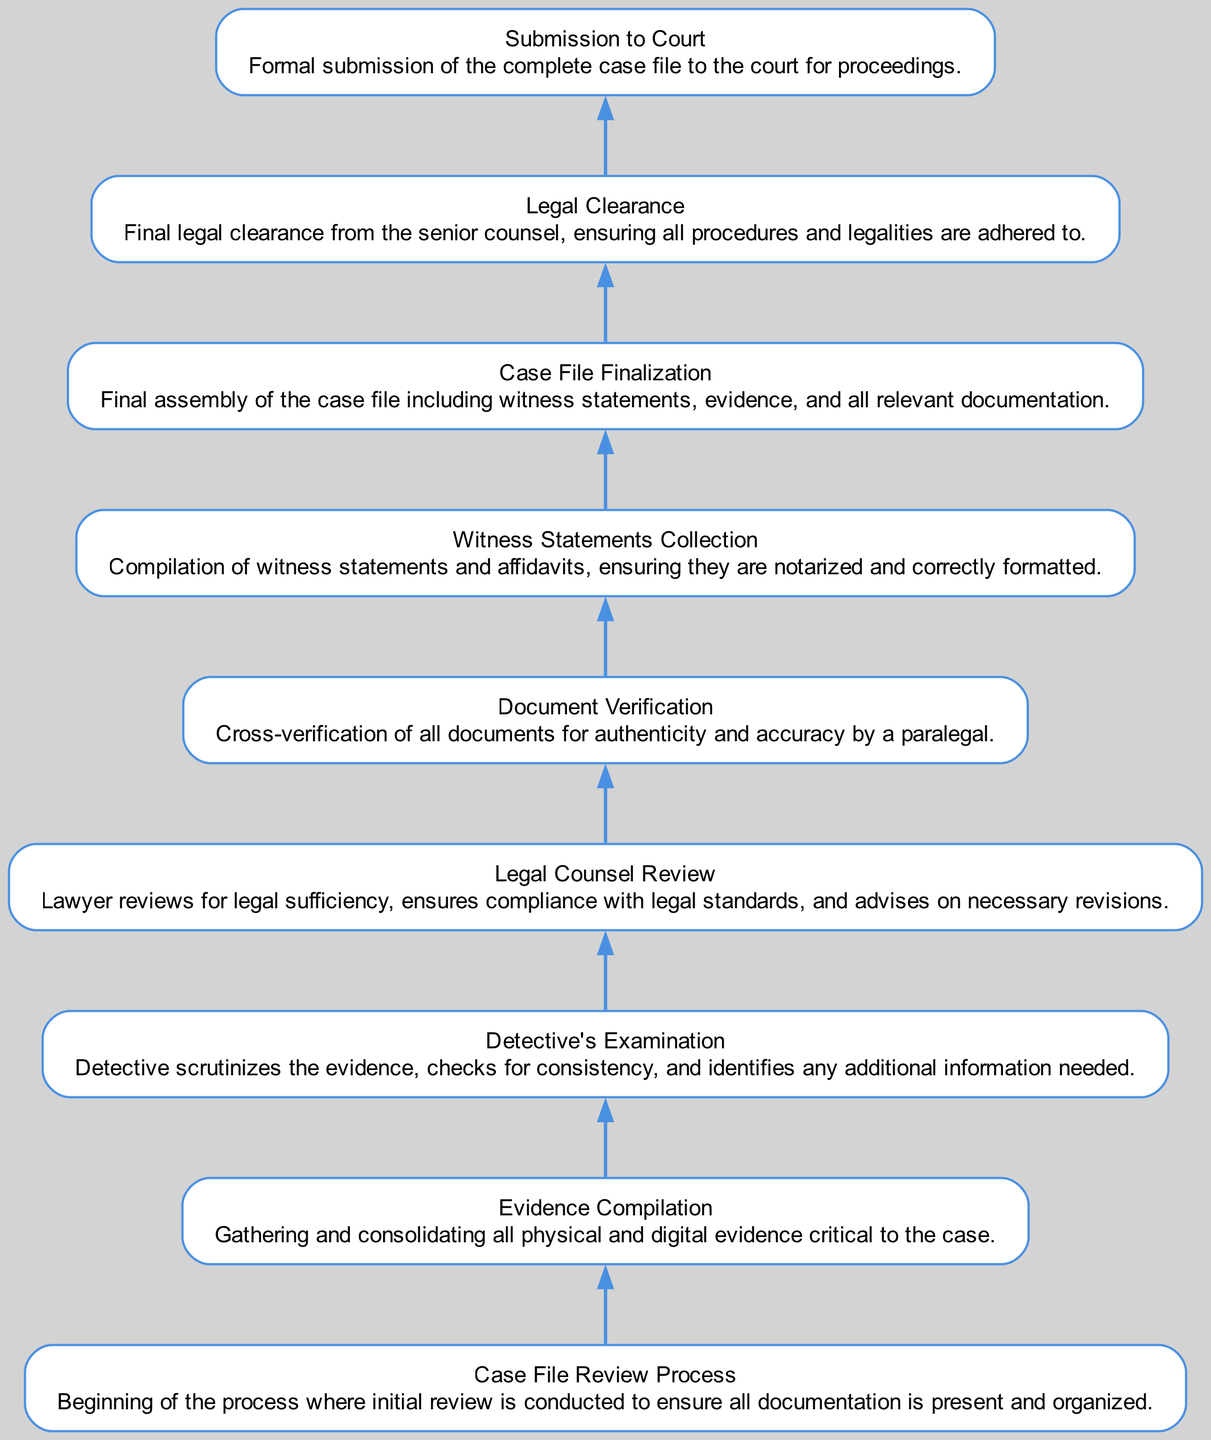What is the first step in the case file review process? The first step described in the diagram is "Case File Review Process," where the initial review is conducted to ensure all documentation is present and organized.
Answer: Case File Review Process How many total steps are there in the flowchart? By counting each distinct element in the diagram, there are nine steps listed in the case file review process.
Answer: Nine What is the function of "Document Verification" in the process? "Document Verification" involves the cross-verification of all documents for authenticity and accuracy by a paralegal, ensuring that all documentation is legally sound before submission.
Answer: Cross-verification Which step follows "Legal Counsel Review"? After "Legal Counsel Review," the next step in the process is "Document Verification." This transition indicates that after the legal review, verification of documents occurs.
Answer: Document Verification What happens immediately after "Case File Finalization"? Following "Case File Finalization," the next step is "Legal Clearance." This indicates that once the case file is finalized, it undergoes final legal review and approval.
Answer: Legal Clearance What is the purpose of "Legal Clearance" in the diagram? "Legal Clearance" serves to ensure that all procedures and legalities are adhered to before the formal submission to the court, thereby providing a final check by senior counsel.
Answer: Final legal approval How are "Witness Statements Collection" and "Document Verification" related in the process? "Witness Statements Collection" needs to occur before "Document Verification" because the accuracy of witness statements must be confirmed during the verification process before the file can progress.
Answer: Sequential steps If all steps are completed without issues, what is the final outcome in the diagram? The final outcome, after completing all steps in the process, is "Submission to Court." This represents the completion of the review process leading to the formal submission of the case file.
Answer: Submission to Court 